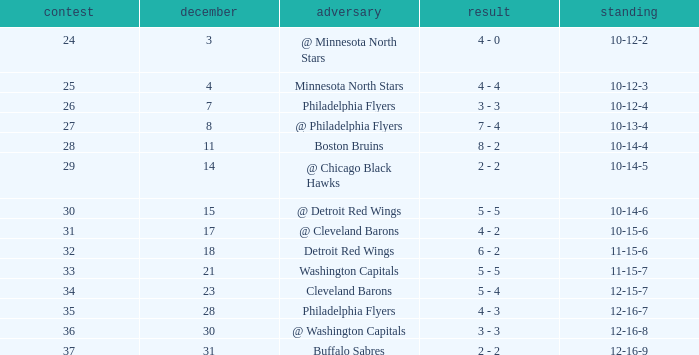What is Record, when Game is "24"? 10-12-2. 